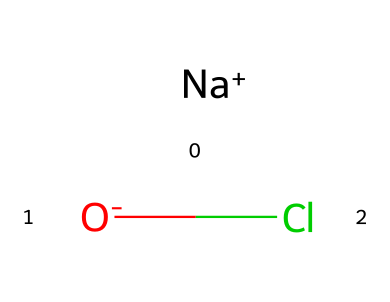What is the chemical name of this compound? The provided SMILES representation corresponds to sodium hypochlorite, which is derived from the elements sodium, oxygen, and chlorine. Sodium is represented by "Na", oxygen by "O", and chlorine by "Cl". The presence of the sodium cation and hypochlorite anion indicates the compound's identity.
Answer: sodium hypochlorite How many atoms are present in this chemical structure? In the SMILES representation, there are three distinct atoms: one sodium (Na), one oxygen (O), and one chlorine (Cl). Counting these gives a total of three atoms.
Answer: three What type of chemical bond is present between the oxygen and chlorine? The bond between oxygen and chlorine in this compound is a covalent bond, as both elements share electrons. This is typical for such compounds where nonmetals bond together.
Answer: covalent What charge does the hypochlorite ion carry? In the SMILES representation, the notation "[O-]Cl" indicates that the oxygen atom is negatively charged, making the hypochlorite ion (ClO-) overall negatively charged.
Answer: negative Is sodium hypochlorite a strong or weak oxidizing agent? Sodium hypochlorite is considered a strong oxidizing agent due to its tendency to readily accept electrons in reactions, particularly during disinfection processes, which kills bacteria.
Answer: strong What is the significance of sodium in this compound? Sodium serves as a counterion that balances the negative charge of the hypochlorite ion, stabilizing the overall compound and allowing it to exist in a usable form for disinfection.
Answer: counterion 